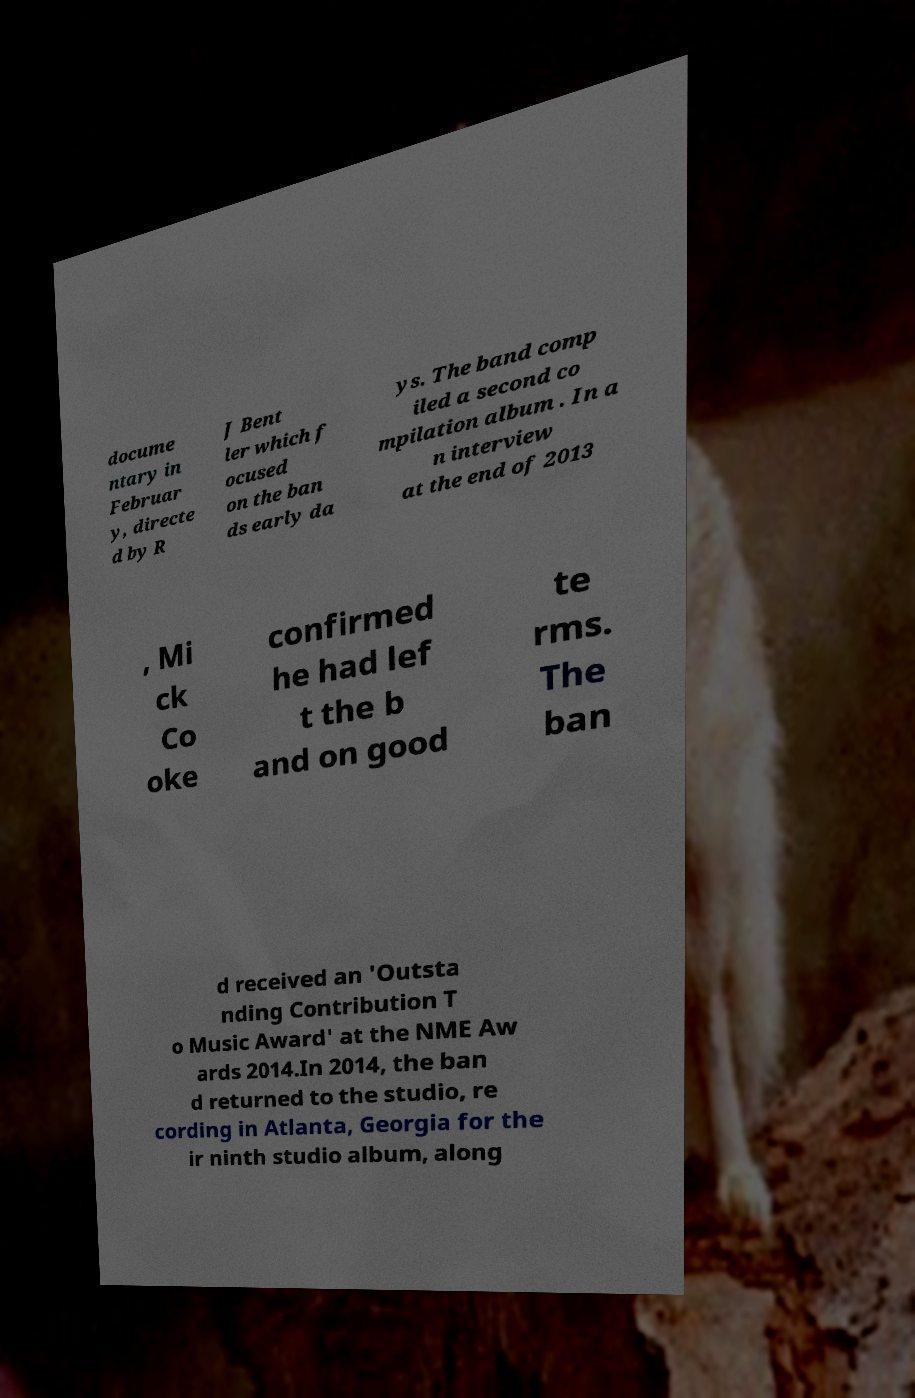Can you accurately transcribe the text from the provided image for me? docume ntary in Februar y, directe d by R J Bent ler which f ocused on the ban ds early da ys. The band comp iled a second co mpilation album . In a n interview at the end of 2013 , Mi ck Co oke confirmed he had lef t the b and on good te rms. The ban d received an 'Outsta nding Contribution T o Music Award' at the NME Aw ards 2014.In 2014, the ban d returned to the studio, re cording in Atlanta, Georgia for the ir ninth studio album, along 